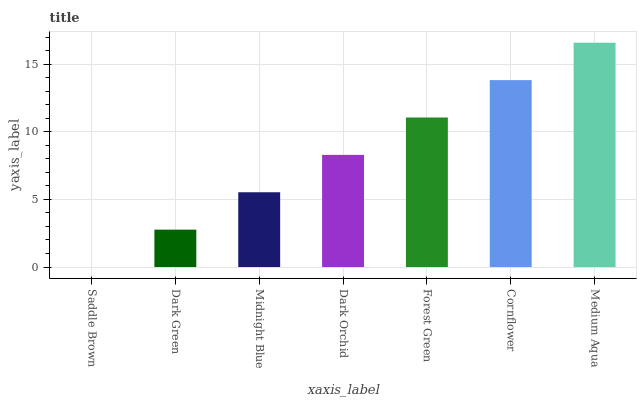Is Saddle Brown the minimum?
Answer yes or no. Yes. Is Medium Aqua the maximum?
Answer yes or no. Yes. Is Dark Green the minimum?
Answer yes or no. No. Is Dark Green the maximum?
Answer yes or no. No. Is Dark Green greater than Saddle Brown?
Answer yes or no. Yes. Is Saddle Brown less than Dark Green?
Answer yes or no. Yes. Is Saddle Brown greater than Dark Green?
Answer yes or no. No. Is Dark Green less than Saddle Brown?
Answer yes or no. No. Is Dark Orchid the high median?
Answer yes or no. Yes. Is Dark Orchid the low median?
Answer yes or no. Yes. Is Medium Aqua the high median?
Answer yes or no. No. Is Cornflower the low median?
Answer yes or no. No. 